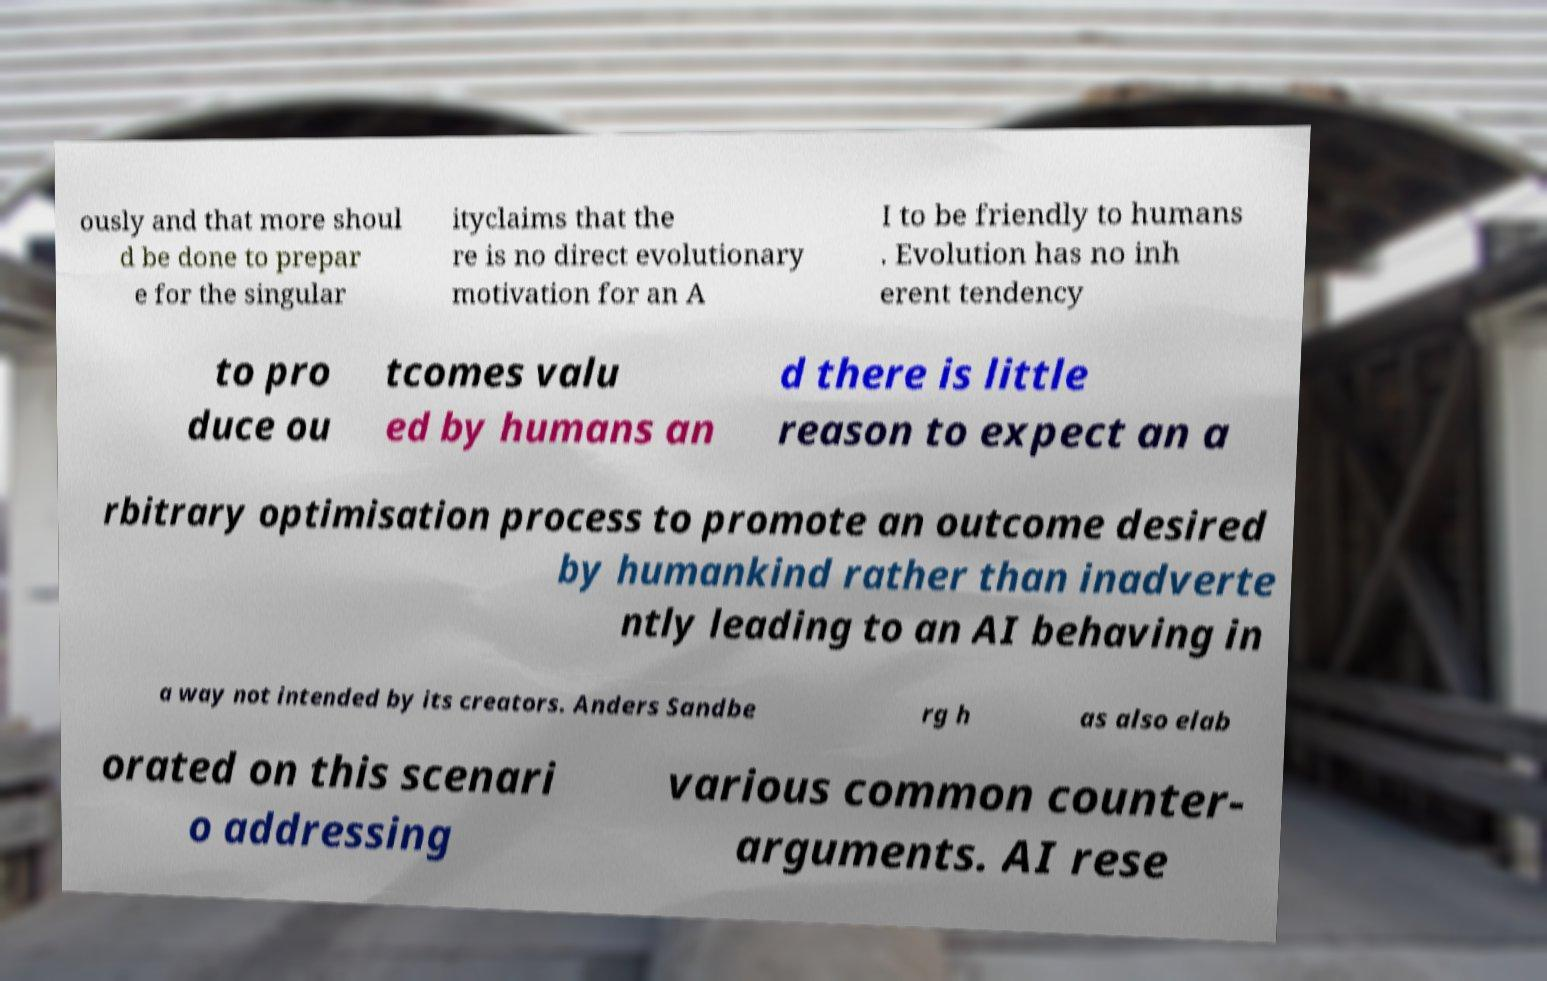Could you assist in decoding the text presented in this image and type it out clearly? ously and that more shoul d be done to prepar e for the singular ityclaims that the re is no direct evolutionary motivation for an A I to be friendly to humans . Evolution has no inh erent tendency to pro duce ou tcomes valu ed by humans an d there is little reason to expect an a rbitrary optimisation process to promote an outcome desired by humankind rather than inadverte ntly leading to an AI behaving in a way not intended by its creators. Anders Sandbe rg h as also elab orated on this scenari o addressing various common counter- arguments. AI rese 